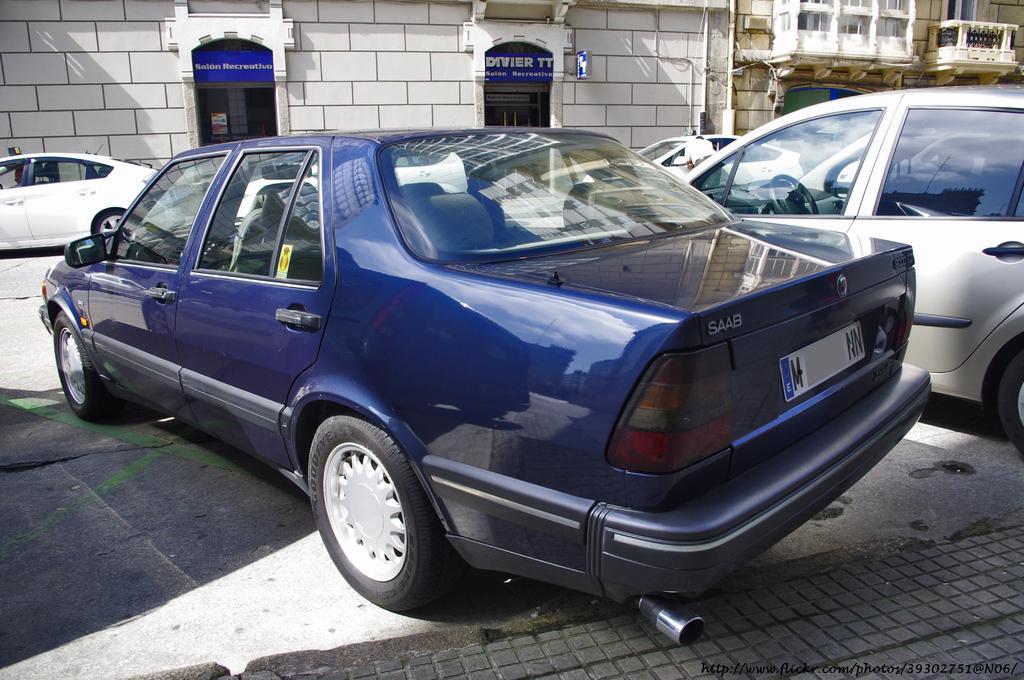Could you give a brief overview of what you see in this image? In the picture we can see a path with a car parked on it which is blue in color and beside we can see a white color car and opposite side also we can see two cars are parked near the building and beside it we can see another building. 